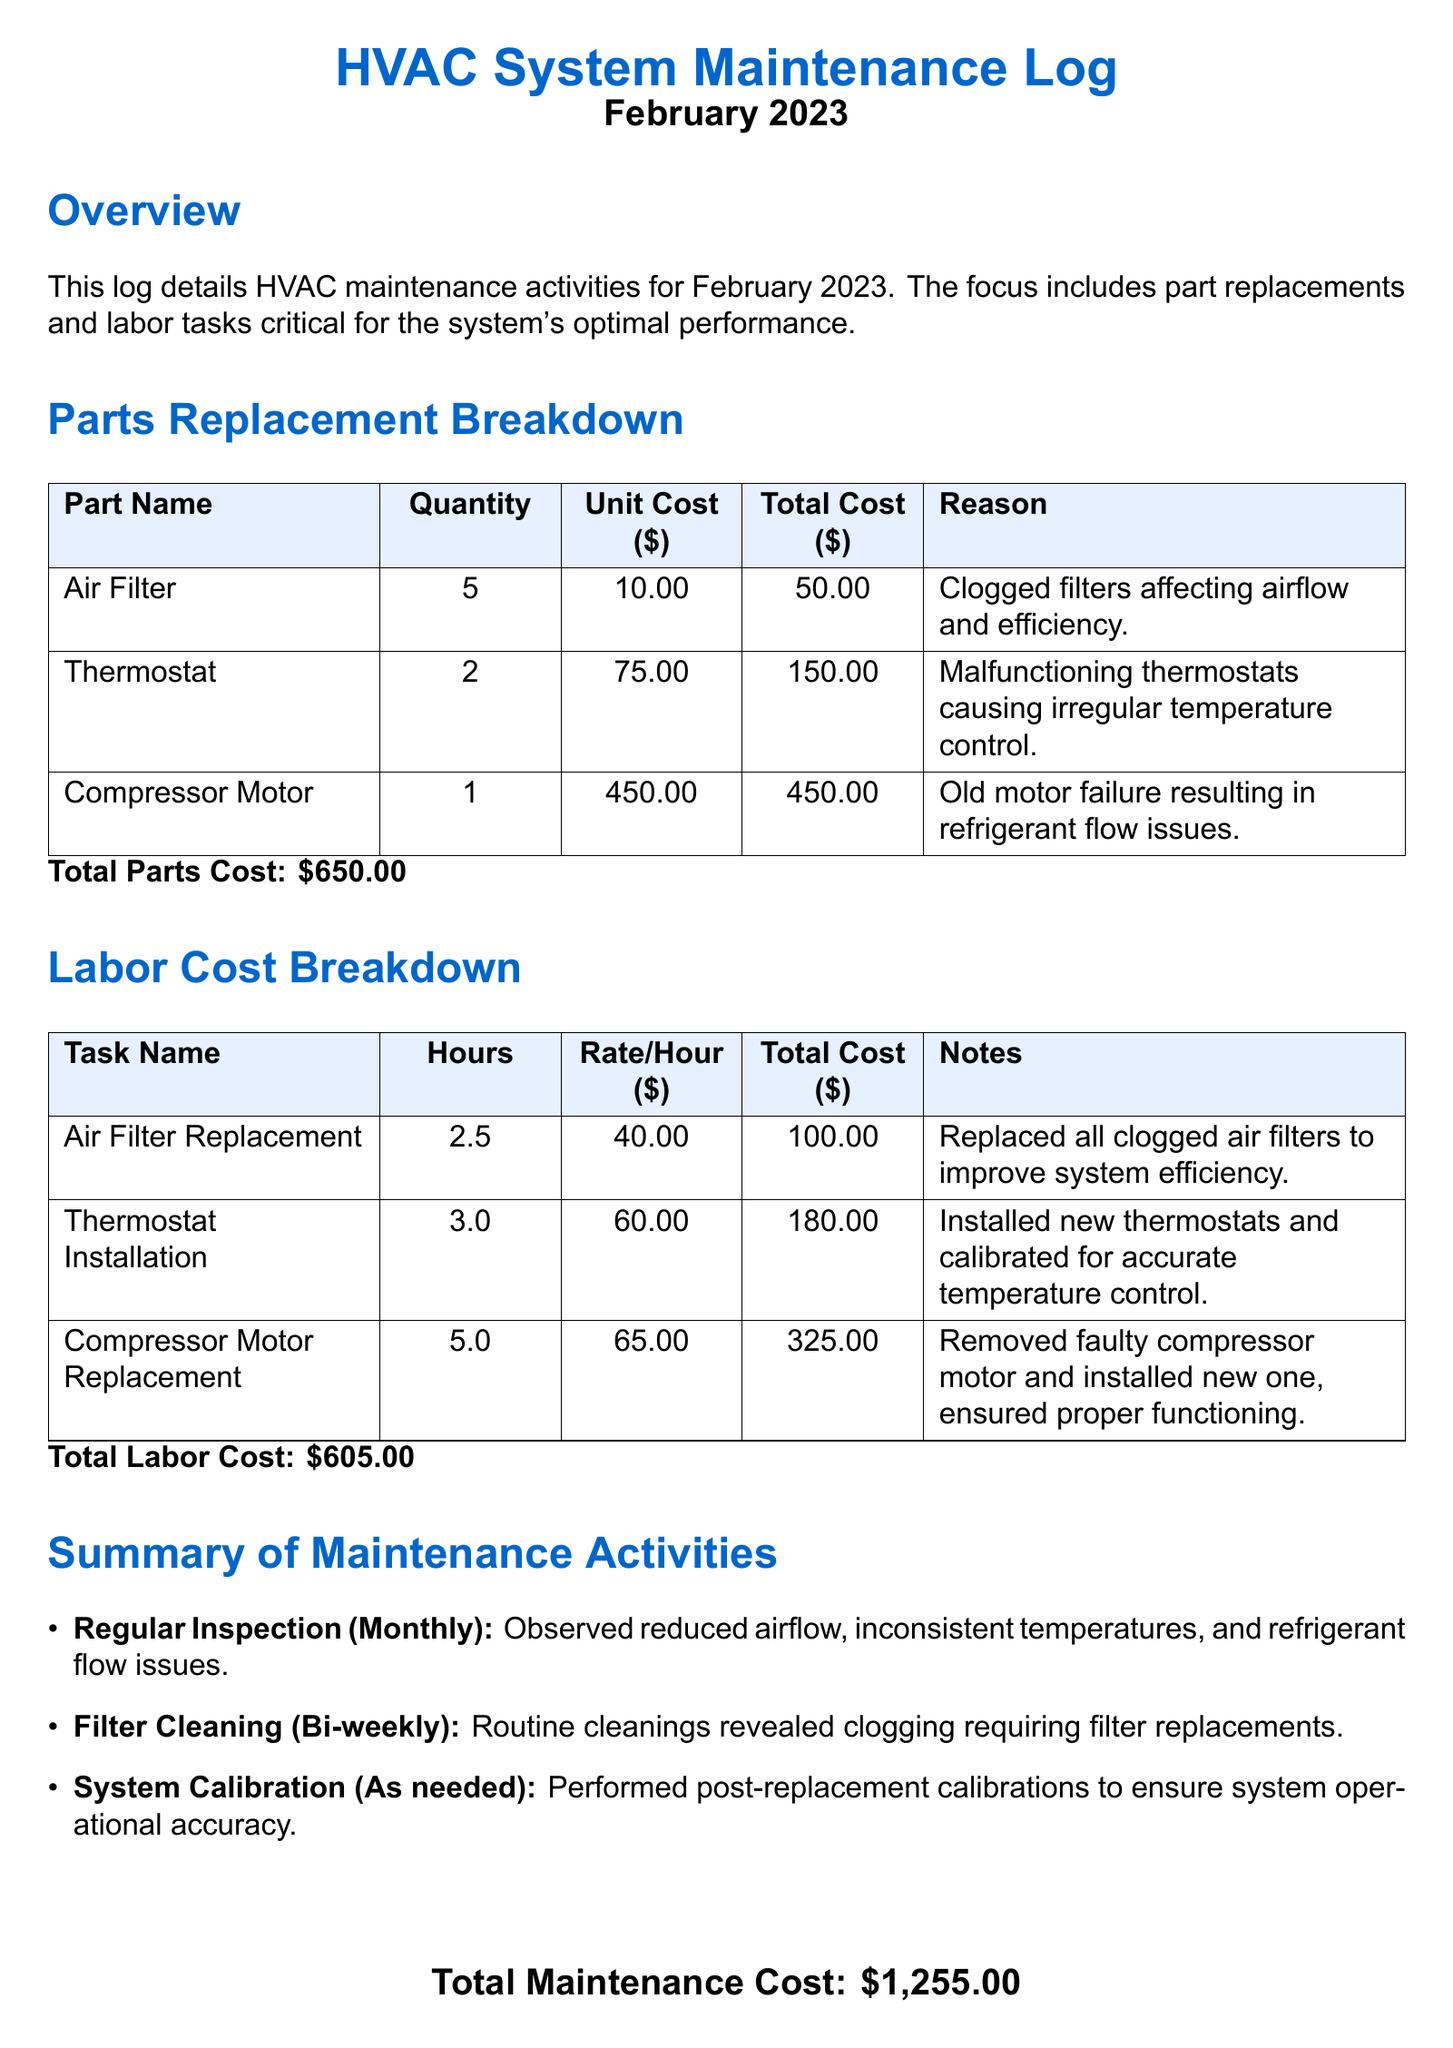What is the total parts cost? The total parts cost is the sum of all part replacement costs listed, which is $650.00.
Answer: $650.00 How many air filters were replaced? The document states that 5 air filters were replaced.
Answer: 5 What was the unit cost of the thermostat? The document indicates that the unit cost of each thermostat is $75.00.
Answer: $75.00 What is the total labor cost? The total labor cost is summarized in the document, which is $605.00.
Answer: $605.00 Why were the air filters replaced? The reason given for replacing the air filters is because of clogged filters affecting airflow and efficiency.
Answer: Clogged filters affecting airflow and efficiency What was the hourly rate for the compressor motor replacement task? The hourly rate for the compressor motor replacement task is $65.00 per hour.
Answer: $65.00 What type of maintenance was performed bi-weekly? The document specifies that filter cleaning was performed bi-weekly.
Answer: Filter Cleaning What was the total maintenance cost for February 2023? The total maintenance cost is noted at the end of the document, which is $1,255.00.
Answer: $1,255.00 How many hours were spent on thermostat installation? The document states that 3.0 hours were spent on thermostat installation.
Answer: 3.0 Which part was related to refrigerant flow issues? The compressor motor was mentioned in relation to refrigerant flow issues in the document.
Answer: Compressor Motor 